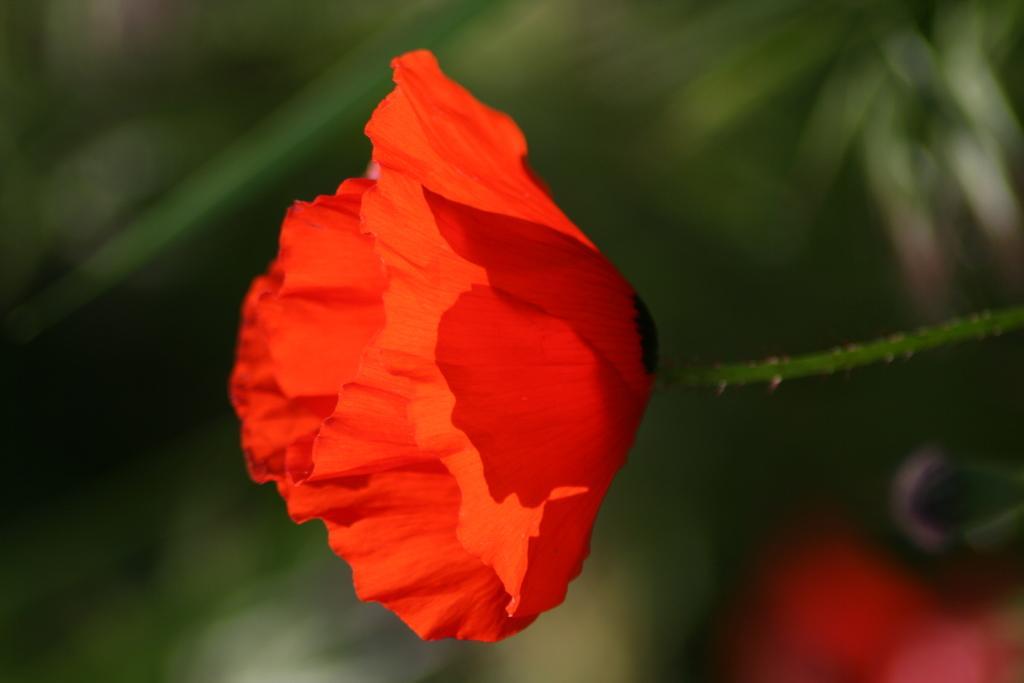Could you give a brief overview of what you see in this image? Here we can see red flower. Background it is blur. 